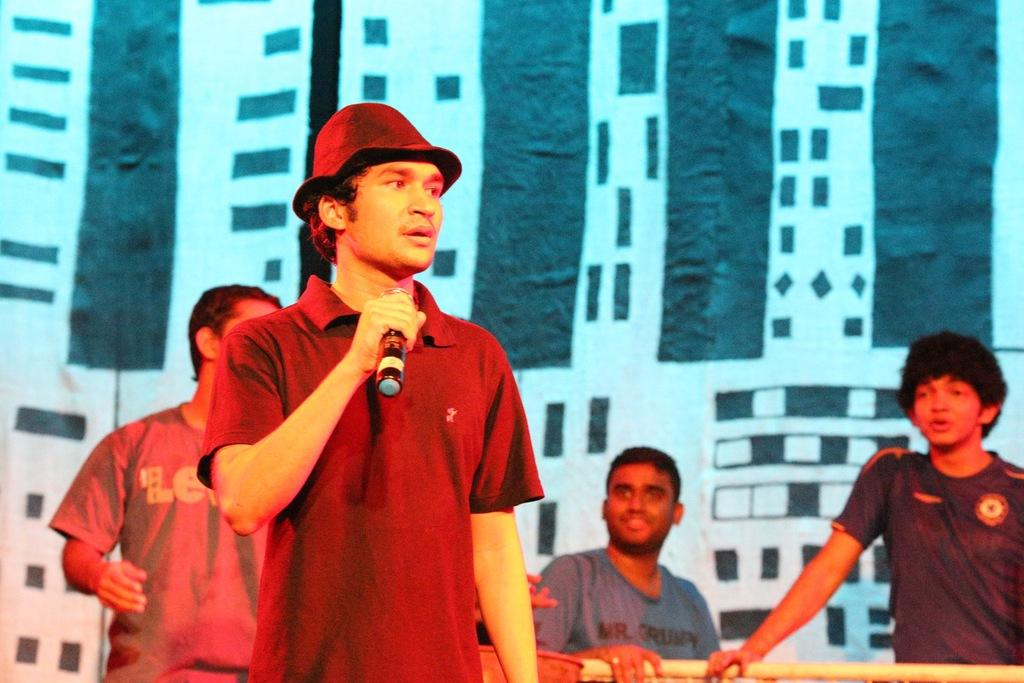How many people are in the image? There are four men in the image. Can you describe any specific clothing or accessories worn by the men? One man is wearing a cap. What is one man doing in the image? One man is holding a microphone. Can you describe the facial expression of one of the men? One man is smiling. What type of fruit is being offered to the men in the image? There is no fruit present in the image. Can you describe the wilderness setting in the image? The image does not depict a wilderness setting; it appears to be an indoor location. 